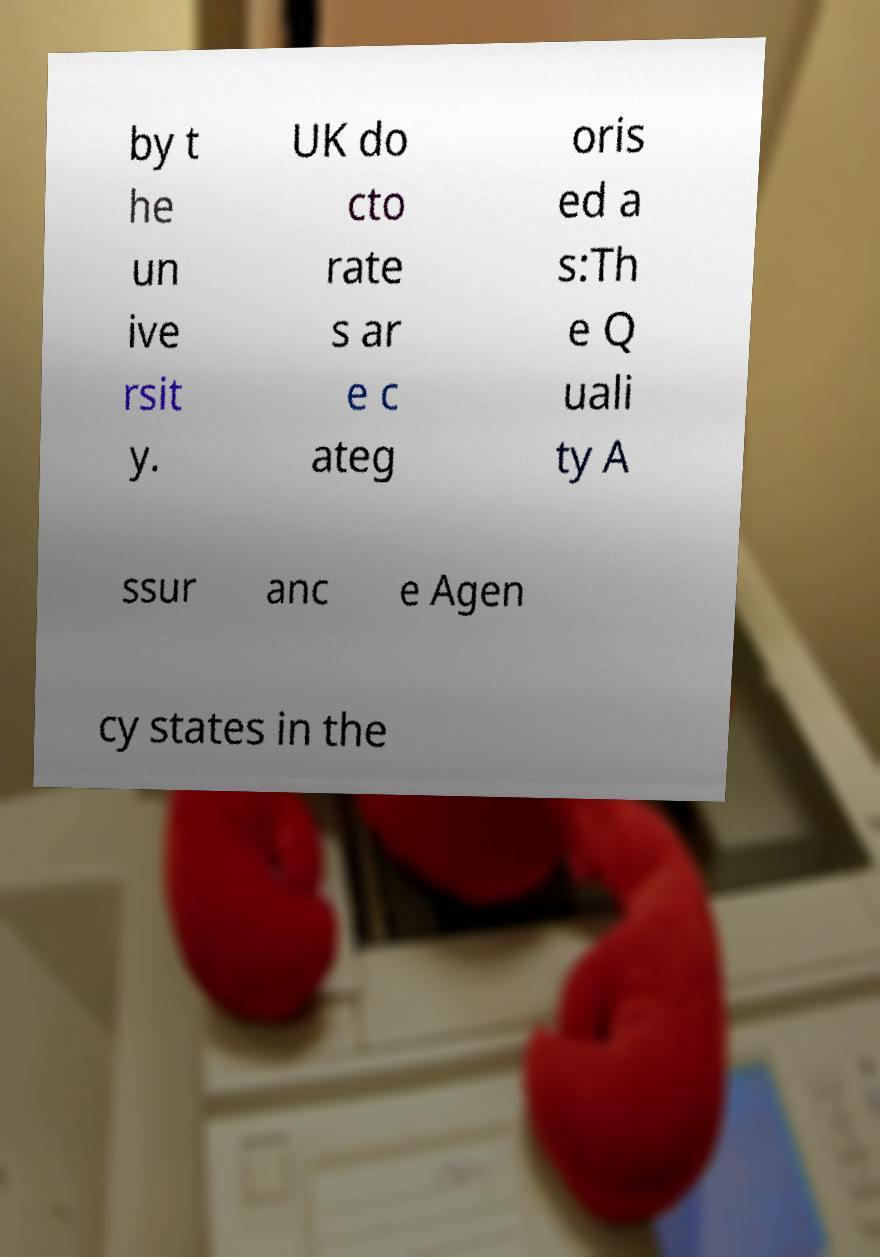There's text embedded in this image that I need extracted. Can you transcribe it verbatim? by t he un ive rsit y. UK do cto rate s ar e c ateg oris ed a s:Th e Q uali ty A ssur anc e Agen cy states in the 